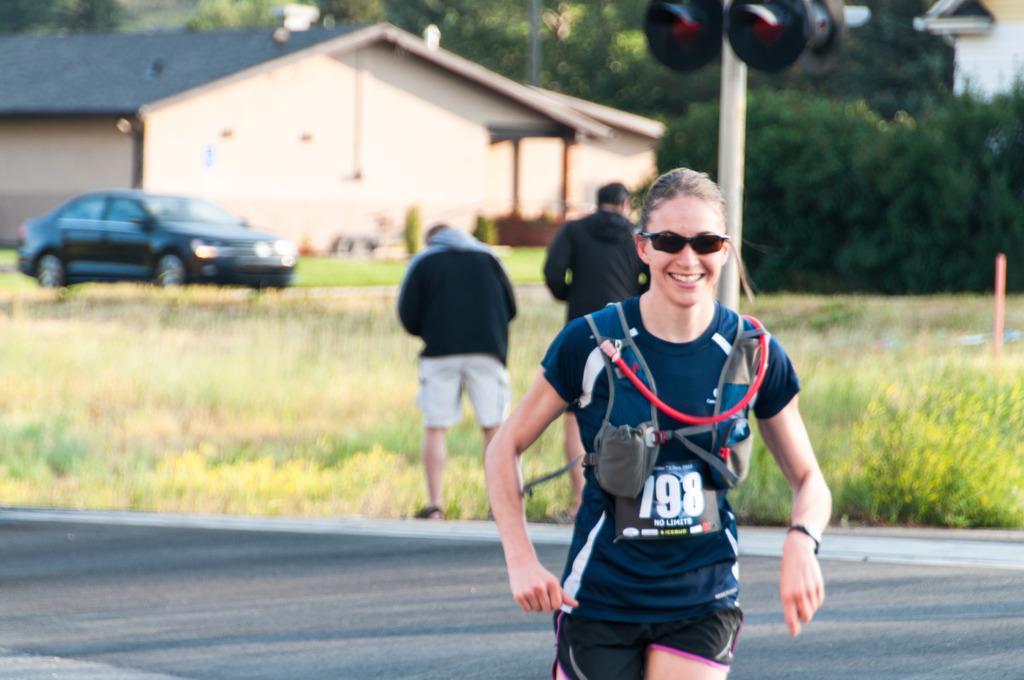In one or two sentences, can you explain what this image depicts? In the image we can see there is a woman standing and wearing sunglasses. There are people standing on the ground and the ground is covered with grass. There are trees and there is a building. Behind there is car parked on the ground. 